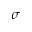Convert formula to latex. <formula><loc_0><loc_0><loc_500><loc_500>\sigma</formula> 